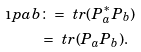<formula> <loc_0><loc_0><loc_500><loc_500>\i p { a } { b } & \colon = \ t r ( P _ { a } ^ { * } P _ { b } ) \\ & = \ t r ( P _ { a } P _ { b } ) .</formula> 